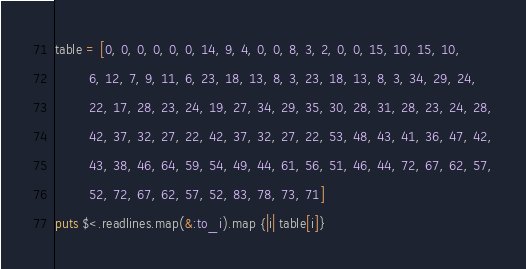Convert code to text. <code><loc_0><loc_0><loc_500><loc_500><_Ruby_>table = [0, 0, 0, 0, 0, 0, 14, 9, 4, 0, 0, 8, 3, 2, 0, 0, 15, 10, 15, 10,
         6, 12, 7, 9, 11, 6, 23, 18, 13, 8, 3, 23, 18, 13, 8, 3, 34, 29, 24,
         22, 17, 28, 23, 24, 19, 27, 34, 29, 35, 30, 28, 31, 28, 23, 24, 28,
         42, 37, 32, 27, 22, 42, 37, 32, 27, 22, 53, 48, 43, 41, 36, 47, 42,
         43, 38, 46, 64, 59, 54, 49, 44, 61, 56, 51, 46, 44, 72, 67, 62, 57,
         52, 72, 67, 62, 57, 52, 83, 78, 73, 71]
puts $<.readlines.map(&:to_i).map {|i| table[i]}
</code> 